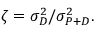<formula> <loc_0><loc_0><loc_500><loc_500>\zeta = \sigma _ { D } ^ { 2 } / \sigma _ { P + D } ^ { 2 } .</formula> 